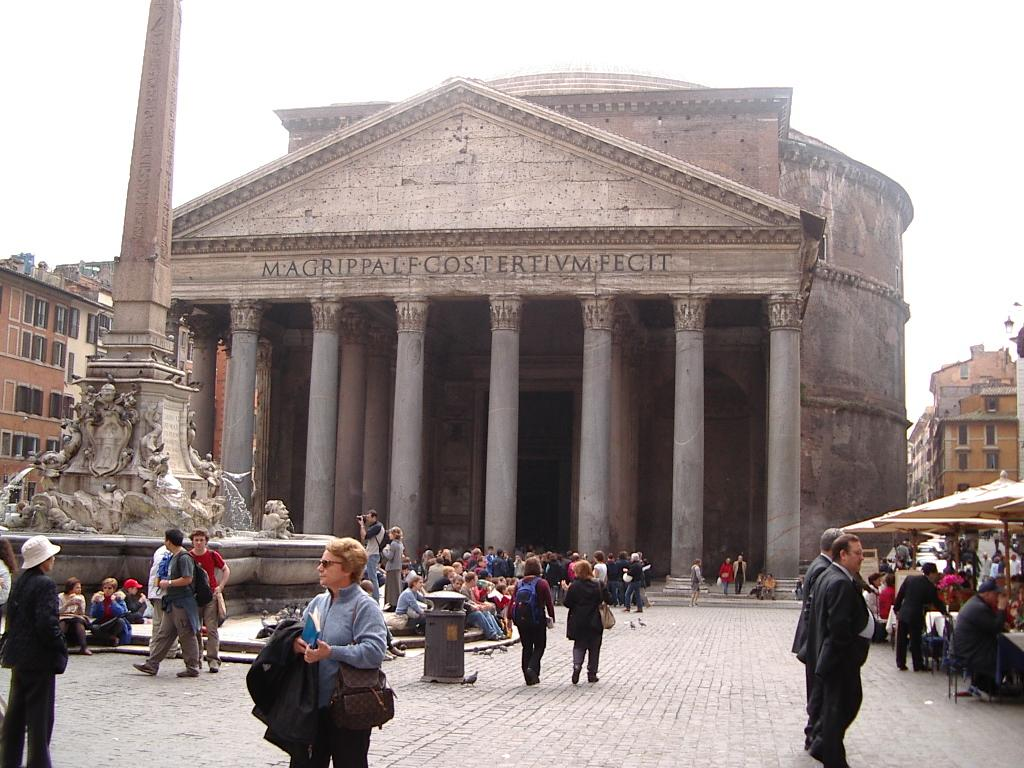How many people are in the image? There is a group of people in the image. What are some of the people in the image doing? Some people are walking, and some people are sitting. What can be seen in the background of the image? There are statues and buildings with cream and white colors in the background. What is the color of the sky in the image? The sky is white in color. Can you tell me the name of the boy in the image? There is no boy present in the image; it features a group of people. What question is being asked by the person in the image? There is no person asking a question in the image; it only shows people walking and sitting. 